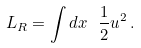Convert formula to latex. <formula><loc_0><loc_0><loc_500><loc_500>L _ { R } = \int d x \ \frac { 1 } { 2 } u ^ { 2 } \, .</formula> 